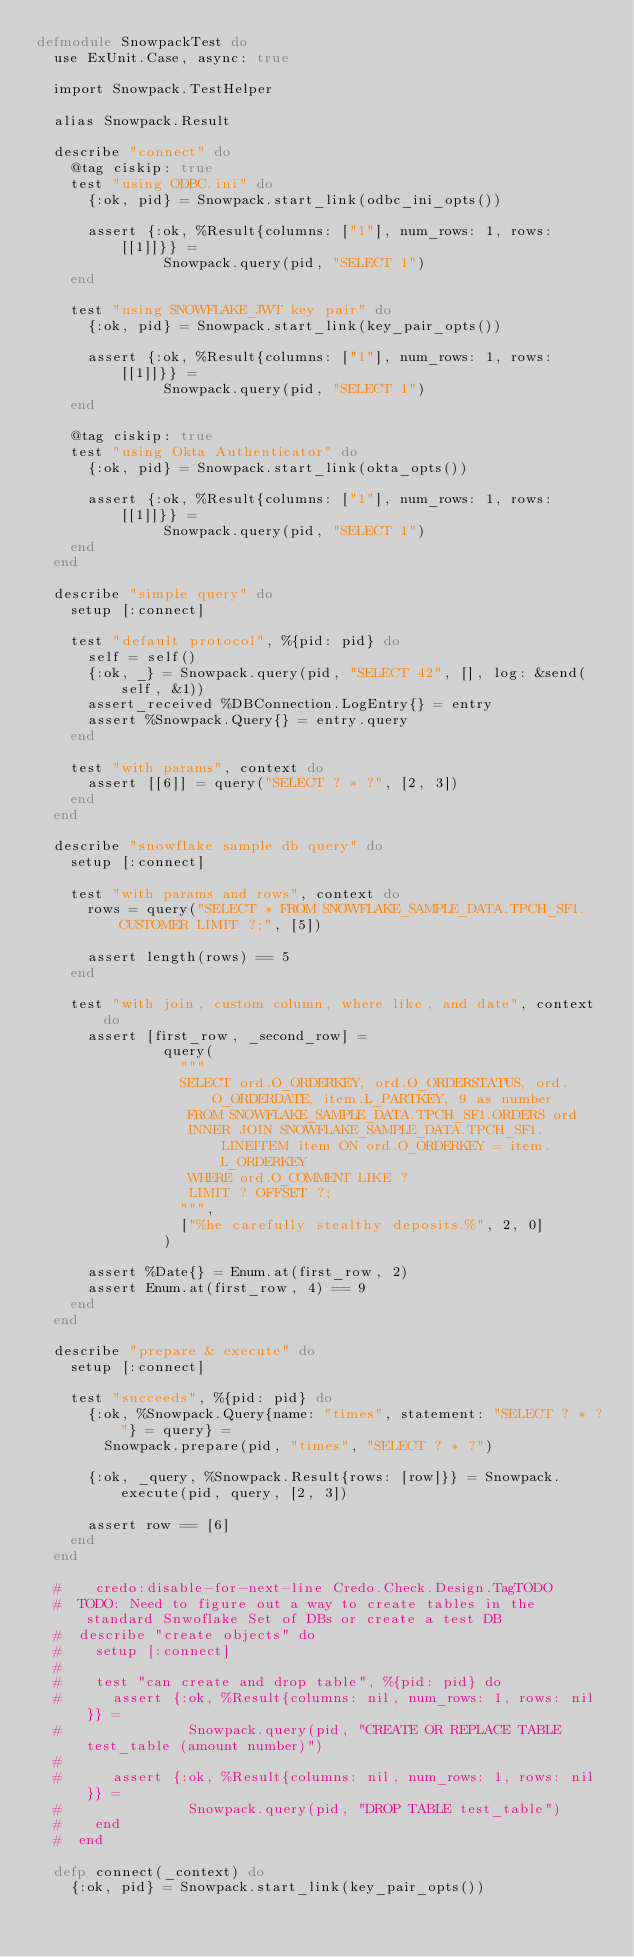<code> <loc_0><loc_0><loc_500><loc_500><_Elixir_>defmodule SnowpackTest do
  use ExUnit.Case, async: true

  import Snowpack.TestHelper

  alias Snowpack.Result

  describe "connect" do
    @tag ciskip: true
    test "using ODBC.ini" do
      {:ok, pid} = Snowpack.start_link(odbc_ini_opts())

      assert {:ok, %Result{columns: ["1"], num_rows: 1, rows: [[1]]}} =
               Snowpack.query(pid, "SELECT 1")
    end

    test "using SNOWFLAKE_JWT key pair" do
      {:ok, pid} = Snowpack.start_link(key_pair_opts())

      assert {:ok, %Result{columns: ["1"], num_rows: 1, rows: [[1]]}} =
               Snowpack.query(pid, "SELECT 1")
    end

    @tag ciskip: true
    test "using Okta Authenticator" do
      {:ok, pid} = Snowpack.start_link(okta_opts())

      assert {:ok, %Result{columns: ["1"], num_rows: 1, rows: [[1]]}} =
               Snowpack.query(pid, "SELECT 1")
    end
  end

  describe "simple query" do
    setup [:connect]

    test "default protocol", %{pid: pid} do
      self = self()
      {:ok, _} = Snowpack.query(pid, "SELECT 42", [], log: &send(self, &1))
      assert_received %DBConnection.LogEntry{} = entry
      assert %Snowpack.Query{} = entry.query
    end

    test "with params", context do
      assert [[6]] = query("SELECT ? * ?", [2, 3])
    end
  end

  describe "snowflake sample db query" do
    setup [:connect]

    test "with params and rows", context do
      rows = query("SELECT * FROM SNOWFLAKE_SAMPLE_DATA.TPCH_SF1.CUSTOMER LIMIT ?;", [5])

      assert length(rows) == 5
    end

    test "with join, custom column, where like, and date", context do
      assert [first_row, _second_row] =
               query(
                 """
                 SELECT ord.O_ORDERKEY, ord.O_ORDERSTATUS, ord.O_ORDERDATE, item.L_PARTKEY, 9 as number
                  FROM SNOWFLAKE_SAMPLE_DATA.TPCH_SF1.ORDERS ord
                  INNER JOIN SNOWFLAKE_SAMPLE_DATA.TPCH_SF1.LINEITEM item ON ord.O_ORDERKEY = item.L_ORDERKEY
                  WHERE ord.O_COMMENT LIKE ?
                  LIMIT ? OFFSET ?;
                 """,
                 ["%he carefully stealthy deposits.%", 2, 0]
               )

      assert %Date{} = Enum.at(first_row, 2)
      assert Enum.at(first_row, 4) == 9
    end
  end

  describe "prepare & execute" do
    setup [:connect]

    test "succeeds", %{pid: pid} do
      {:ok, %Snowpack.Query{name: "times", statement: "SELECT ? * ?"} = query} =
        Snowpack.prepare(pid, "times", "SELECT ? * ?")

      {:ok, _query, %Snowpack.Result{rows: [row]}} = Snowpack.execute(pid, query, [2, 3])

      assert row == [6]
    end
  end

  #    credo:disable-for-next-line Credo.Check.Design.TagTODO
  #  TODO: Need to figure out a way to create tables in the standard Snwoflake Set of DBs or create a test DB
  #  describe "create objects" do
  #    setup [:connect]
  #
  #    test "can create and drop table", %{pid: pid} do
  #      assert {:ok, %Result{columns: nil, num_rows: 1, rows: nil}} =
  #               Snowpack.query(pid, "CREATE OR REPLACE TABLE test_table (amount number)")
  #
  #      assert {:ok, %Result{columns: nil, num_rows: 1, rows: nil}} =
  #               Snowpack.query(pid, "DROP TABLE test_table")
  #    end
  #  end

  defp connect(_context) do
    {:ok, pid} = Snowpack.start_link(key_pair_opts())
</code> 